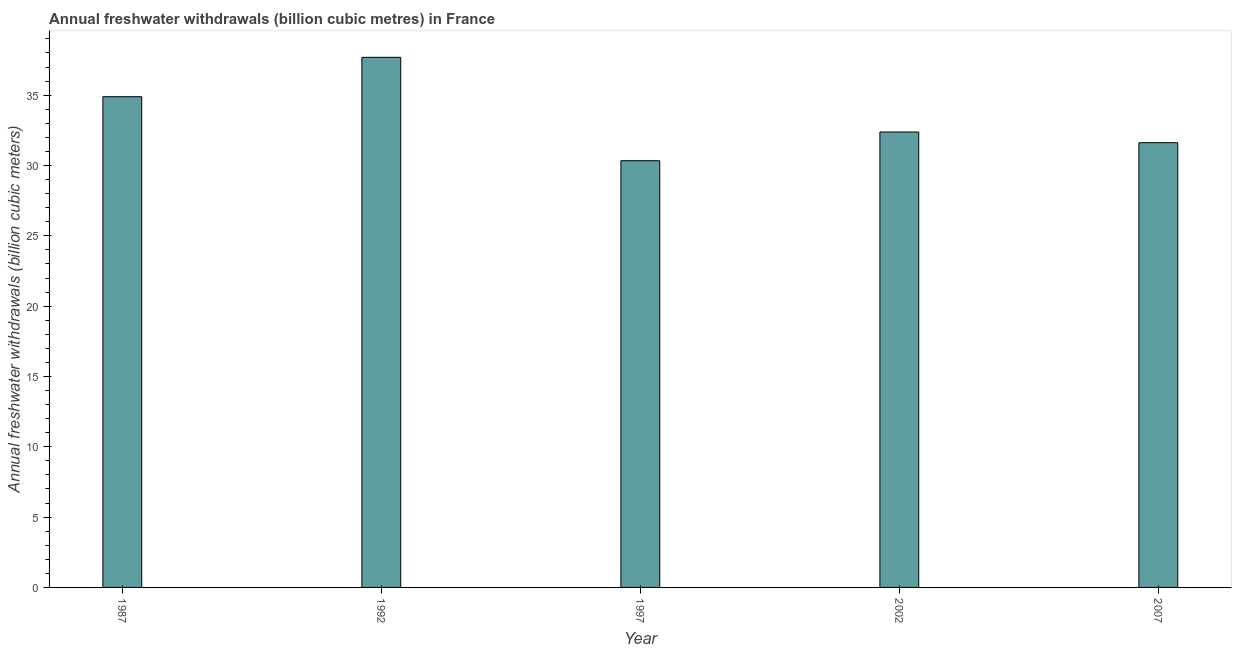Does the graph contain any zero values?
Keep it short and to the point. No. What is the title of the graph?
Your response must be concise. Annual freshwater withdrawals (billion cubic metres) in France. What is the label or title of the X-axis?
Your answer should be compact. Year. What is the label or title of the Y-axis?
Give a very brief answer. Annual freshwater withdrawals (billion cubic meters). What is the annual freshwater withdrawals in 2002?
Ensure brevity in your answer.  32.38. Across all years, what is the maximum annual freshwater withdrawals?
Make the answer very short. 37.69. Across all years, what is the minimum annual freshwater withdrawals?
Provide a succinct answer. 30.34. In which year was the annual freshwater withdrawals maximum?
Offer a terse response. 1992. In which year was the annual freshwater withdrawals minimum?
Keep it short and to the point. 1997. What is the sum of the annual freshwater withdrawals?
Make the answer very short. 166.92. What is the difference between the annual freshwater withdrawals in 1987 and 2002?
Your response must be concise. 2.51. What is the average annual freshwater withdrawals per year?
Give a very brief answer. 33.38. What is the median annual freshwater withdrawals?
Your answer should be very brief. 32.38. What is the ratio of the annual freshwater withdrawals in 1997 to that in 2007?
Ensure brevity in your answer.  0.96. Is the annual freshwater withdrawals in 1992 less than that in 1997?
Keep it short and to the point. No. Is the sum of the annual freshwater withdrawals in 1987 and 2007 greater than the maximum annual freshwater withdrawals across all years?
Make the answer very short. Yes. What is the difference between the highest and the lowest annual freshwater withdrawals?
Offer a very short reply. 7.35. What is the difference between two consecutive major ticks on the Y-axis?
Offer a very short reply. 5. Are the values on the major ticks of Y-axis written in scientific E-notation?
Ensure brevity in your answer.  No. What is the Annual freshwater withdrawals (billion cubic meters) of 1987?
Keep it short and to the point. 34.89. What is the Annual freshwater withdrawals (billion cubic meters) in 1992?
Give a very brief answer. 37.69. What is the Annual freshwater withdrawals (billion cubic meters) in 1997?
Give a very brief answer. 30.34. What is the Annual freshwater withdrawals (billion cubic meters) in 2002?
Provide a short and direct response. 32.38. What is the Annual freshwater withdrawals (billion cubic meters) of 2007?
Give a very brief answer. 31.62. What is the difference between the Annual freshwater withdrawals (billion cubic meters) in 1987 and 1997?
Give a very brief answer. 4.55. What is the difference between the Annual freshwater withdrawals (billion cubic meters) in 1987 and 2002?
Give a very brief answer. 2.51. What is the difference between the Annual freshwater withdrawals (billion cubic meters) in 1987 and 2007?
Offer a terse response. 3.27. What is the difference between the Annual freshwater withdrawals (billion cubic meters) in 1992 and 1997?
Give a very brief answer. 7.35. What is the difference between the Annual freshwater withdrawals (billion cubic meters) in 1992 and 2002?
Offer a terse response. 5.31. What is the difference between the Annual freshwater withdrawals (billion cubic meters) in 1992 and 2007?
Ensure brevity in your answer.  6.07. What is the difference between the Annual freshwater withdrawals (billion cubic meters) in 1997 and 2002?
Provide a succinct answer. -2.04. What is the difference between the Annual freshwater withdrawals (billion cubic meters) in 1997 and 2007?
Offer a very short reply. -1.28. What is the difference between the Annual freshwater withdrawals (billion cubic meters) in 2002 and 2007?
Give a very brief answer. 0.76. What is the ratio of the Annual freshwater withdrawals (billion cubic meters) in 1987 to that in 1992?
Provide a succinct answer. 0.93. What is the ratio of the Annual freshwater withdrawals (billion cubic meters) in 1987 to that in 1997?
Offer a terse response. 1.15. What is the ratio of the Annual freshwater withdrawals (billion cubic meters) in 1987 to that in 2002?
Your response must be concise. 1.08. What is the ratio of the Annual freshwater withdrawals (billion cubic meters) in 1987 to that in 2007?
Provide a short and direct response. 1.1. What is the ratio of the Annual freshwater withdrawals (billion cubic meters) in 1992 to that in 1997?
Your answer should be compact. 1.24. What is the ratio of the Annual freshwater withdrawals (billion cubic meters) in 1992 to that in 2002?
Provide a short and direct response. 1.16. What is the ratio of the Annual freshwater withdrawals (billion cubic meters) in 1992 to that in 2007?
Offer a terse response. 1.19. What is the ratio of the Annual freshwater withdrawals (billion cubic meters) in 1997 to that in 2002?
Provide a short and direct response. 0.94. What is the ratio of the Annual freshwater withdrawals (billion cubic meters) in 2002 to that in 2007?
Give a very brief answer. 1.02. 